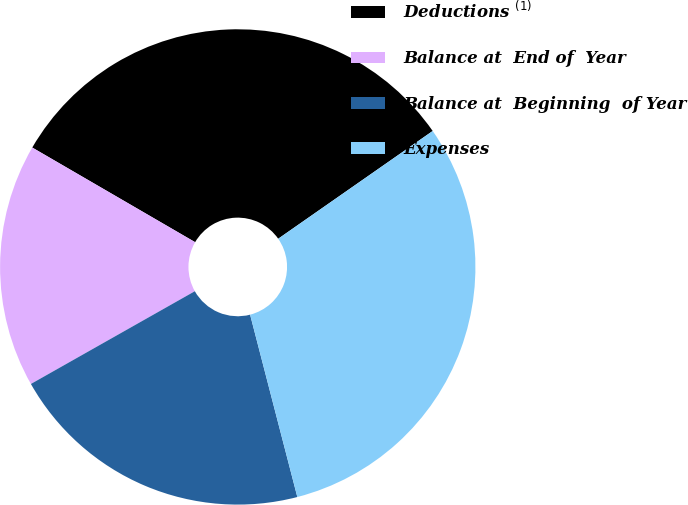Convert chart. <chart><loc_0><loc_0><loc_500><loc_500><pie_chart><fcel>Deductions $^{(1)}$<fcel>Balance at  End of  Year<fcel>Balance at  Beginning  of Year<fcel>Expenses<nl><fcel>31.93%<fcel>16.57%<fcel>20.84%<fcel>30.66%<nl></chart> 